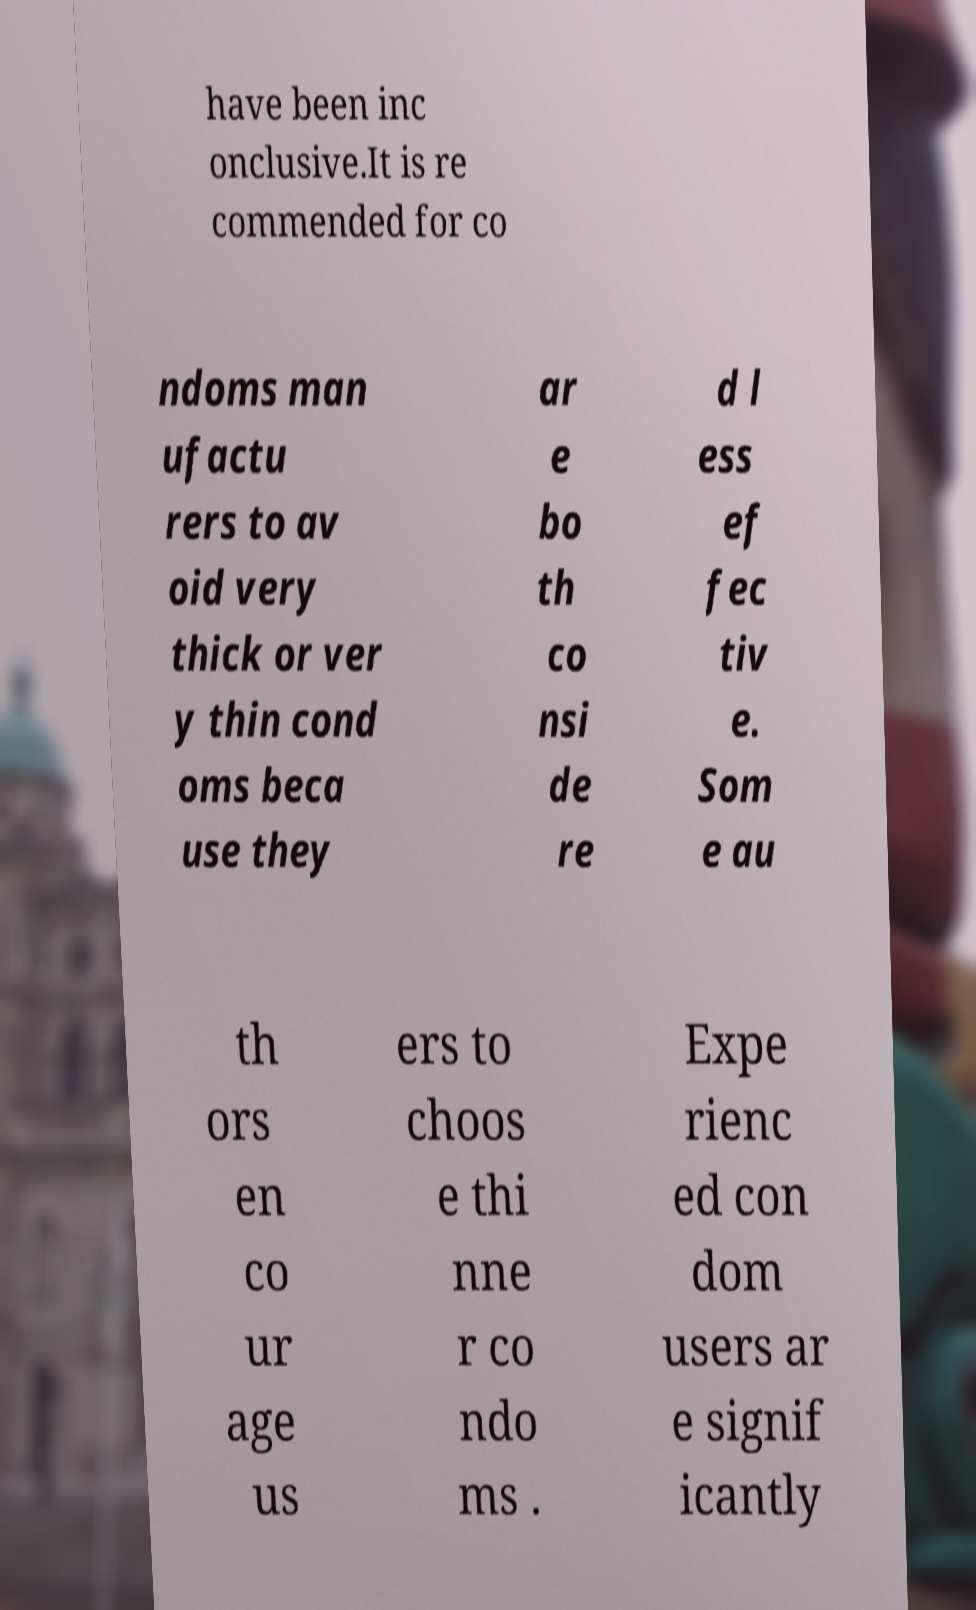Can you accurately transcribe the text from the provided image for me? have been inc onclusive.It is re commended for co ndoms man ufactu rers to av oid very thick or ver y thin cond oms beca use they ar e bo th co nsi de re d l ess ef fec tiv e. Som e au th ors en co ur age us ers to choos e thi nne r co ndo ms . Expe rienc ed con dom users ar e signif icantly 